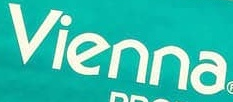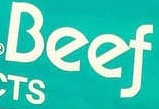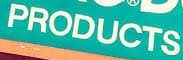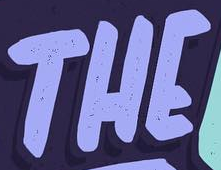Identify the words shown in these images in order, separated by a semicolon. vienna; Beef; PRODUCTS; THE 